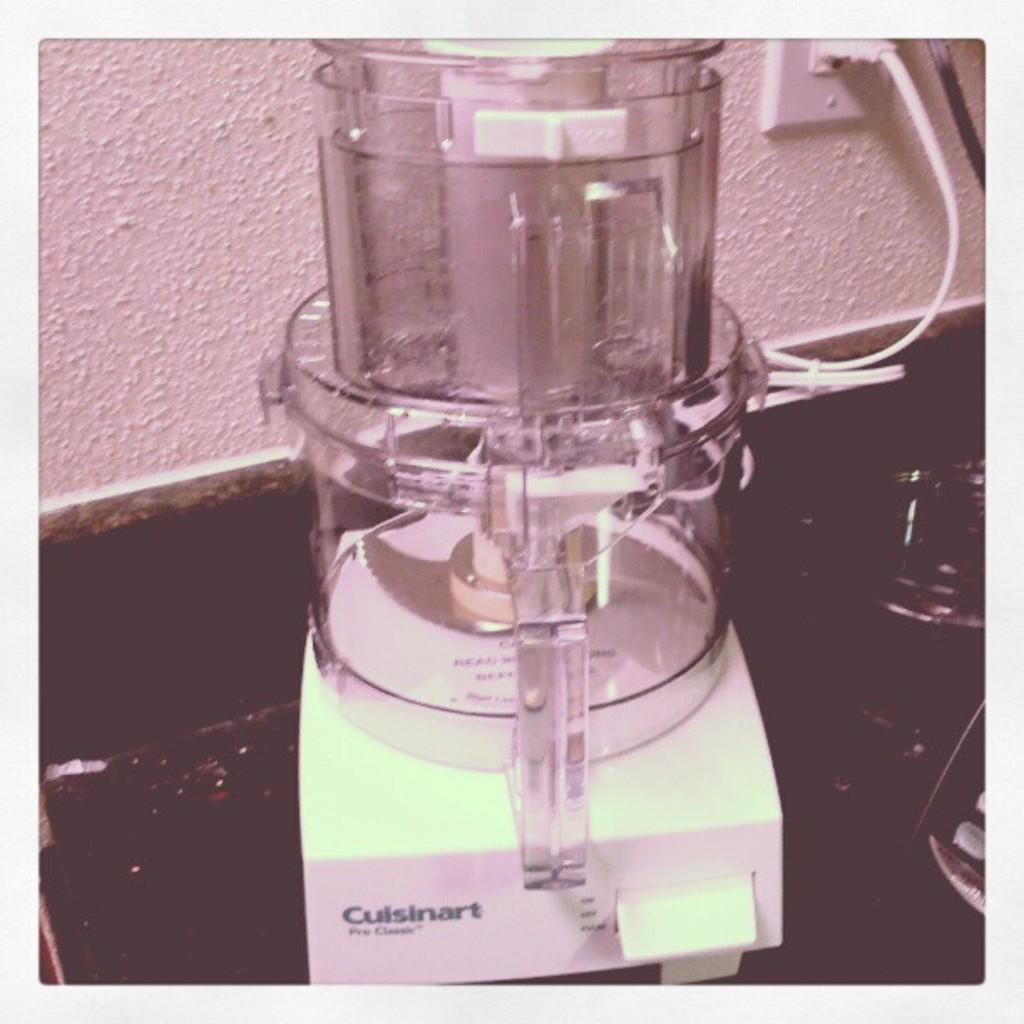Provide a one-sentence caption for the provided image. a picture of a Cuisinart Pro Classic Food Processor that is plugged in. 